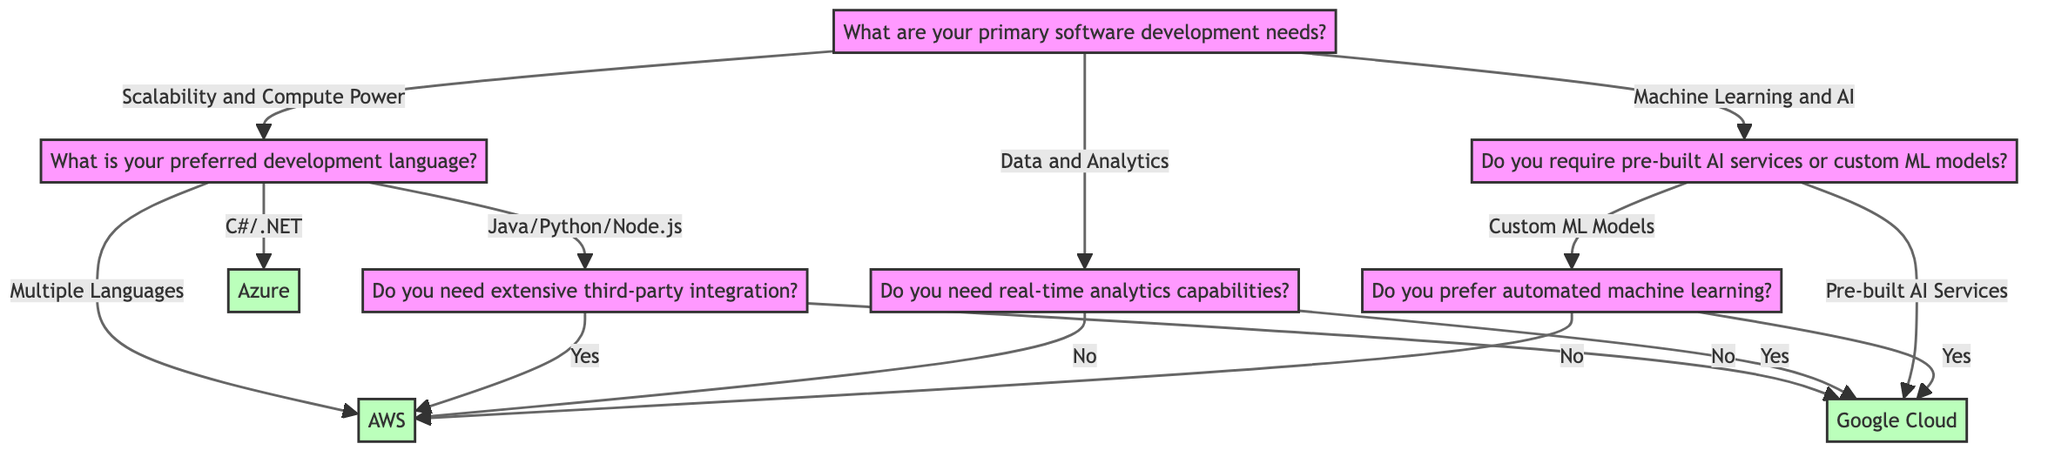What are the three primary software development needs listed in the diagram? The diagram starts with a question about primary software development needs, which shows three options: Scalability and Compute Power, Data and Analytics, and Machine Learning and AI.
Answer: Scalability and Compute Power, Data and Analytics, Machine Learning and AI Which node leads to Azure as a recommendation? The diagram shows that Azure is recommended when the preferred development language is C#/ .NET. Hence, the path that leads to Azure is from the question "What is your preferred development language?" to the answer "C#/ .NET."
Answer: Azure How many total recommendations does the diagram provide? By examining the diagram, there are three distinct recommendations: AWS, Azure, and Google Cloud. Each path through the nodes leads to one of these three service providers.
Answer: Three What is the outcome if the user selects "No" for extensive third-party integration after choosing "Java/Python/Node.js"? Starting from the preferred language "Java/Python/Node.js," when the user selects "No" for the integration question, the next recommendation node in the diagram is Google Cloud.
Answer: Google Cloud If the user selects "No" for real-time analytics capabilities, which recommendation follows? The path starts with the primary needs leading to Data and Analytics. Selecting "No" for real-time analytics leads to the recommendation node for AWS, as indicated in the diagram.
Answer: AWS What question does the pathway for "Custom ML Models" conclude with? The pathway for "Custom ML Models" leads to the question "Do you prefer automated machine learning?" This question branches out into two further recommendations based on the user's preference.
Answer: Do you prefer automated machine learning? Which cloud provider is suggested for "Pre-built AI Services"? The diagram directly connects "Pre-built AI Services" to the recommendation node for Google Cloud. This is indicative of Google's strong offerings in this area.
Answer: Google Cloud How does the decision tree differentiate between data and analytics requirements? The diagram differentiates data and analytics requirements by asking if the user needs real-time analytics capabilities. A "Yes" leads to Google Cloud, while a "No" leads to AWS, illustrating how the need informs the recommendation.
Answer: Real-time analytics capabilities What is the recommendation if a user selects "Yes" for requiring automated machine learning? Following the path for "Custom ML Models" to "Yes" for automated machine learning leads to the recommendation of Google Cloud, as shown in the diagram's outputs.
Answer: Google Cloud 